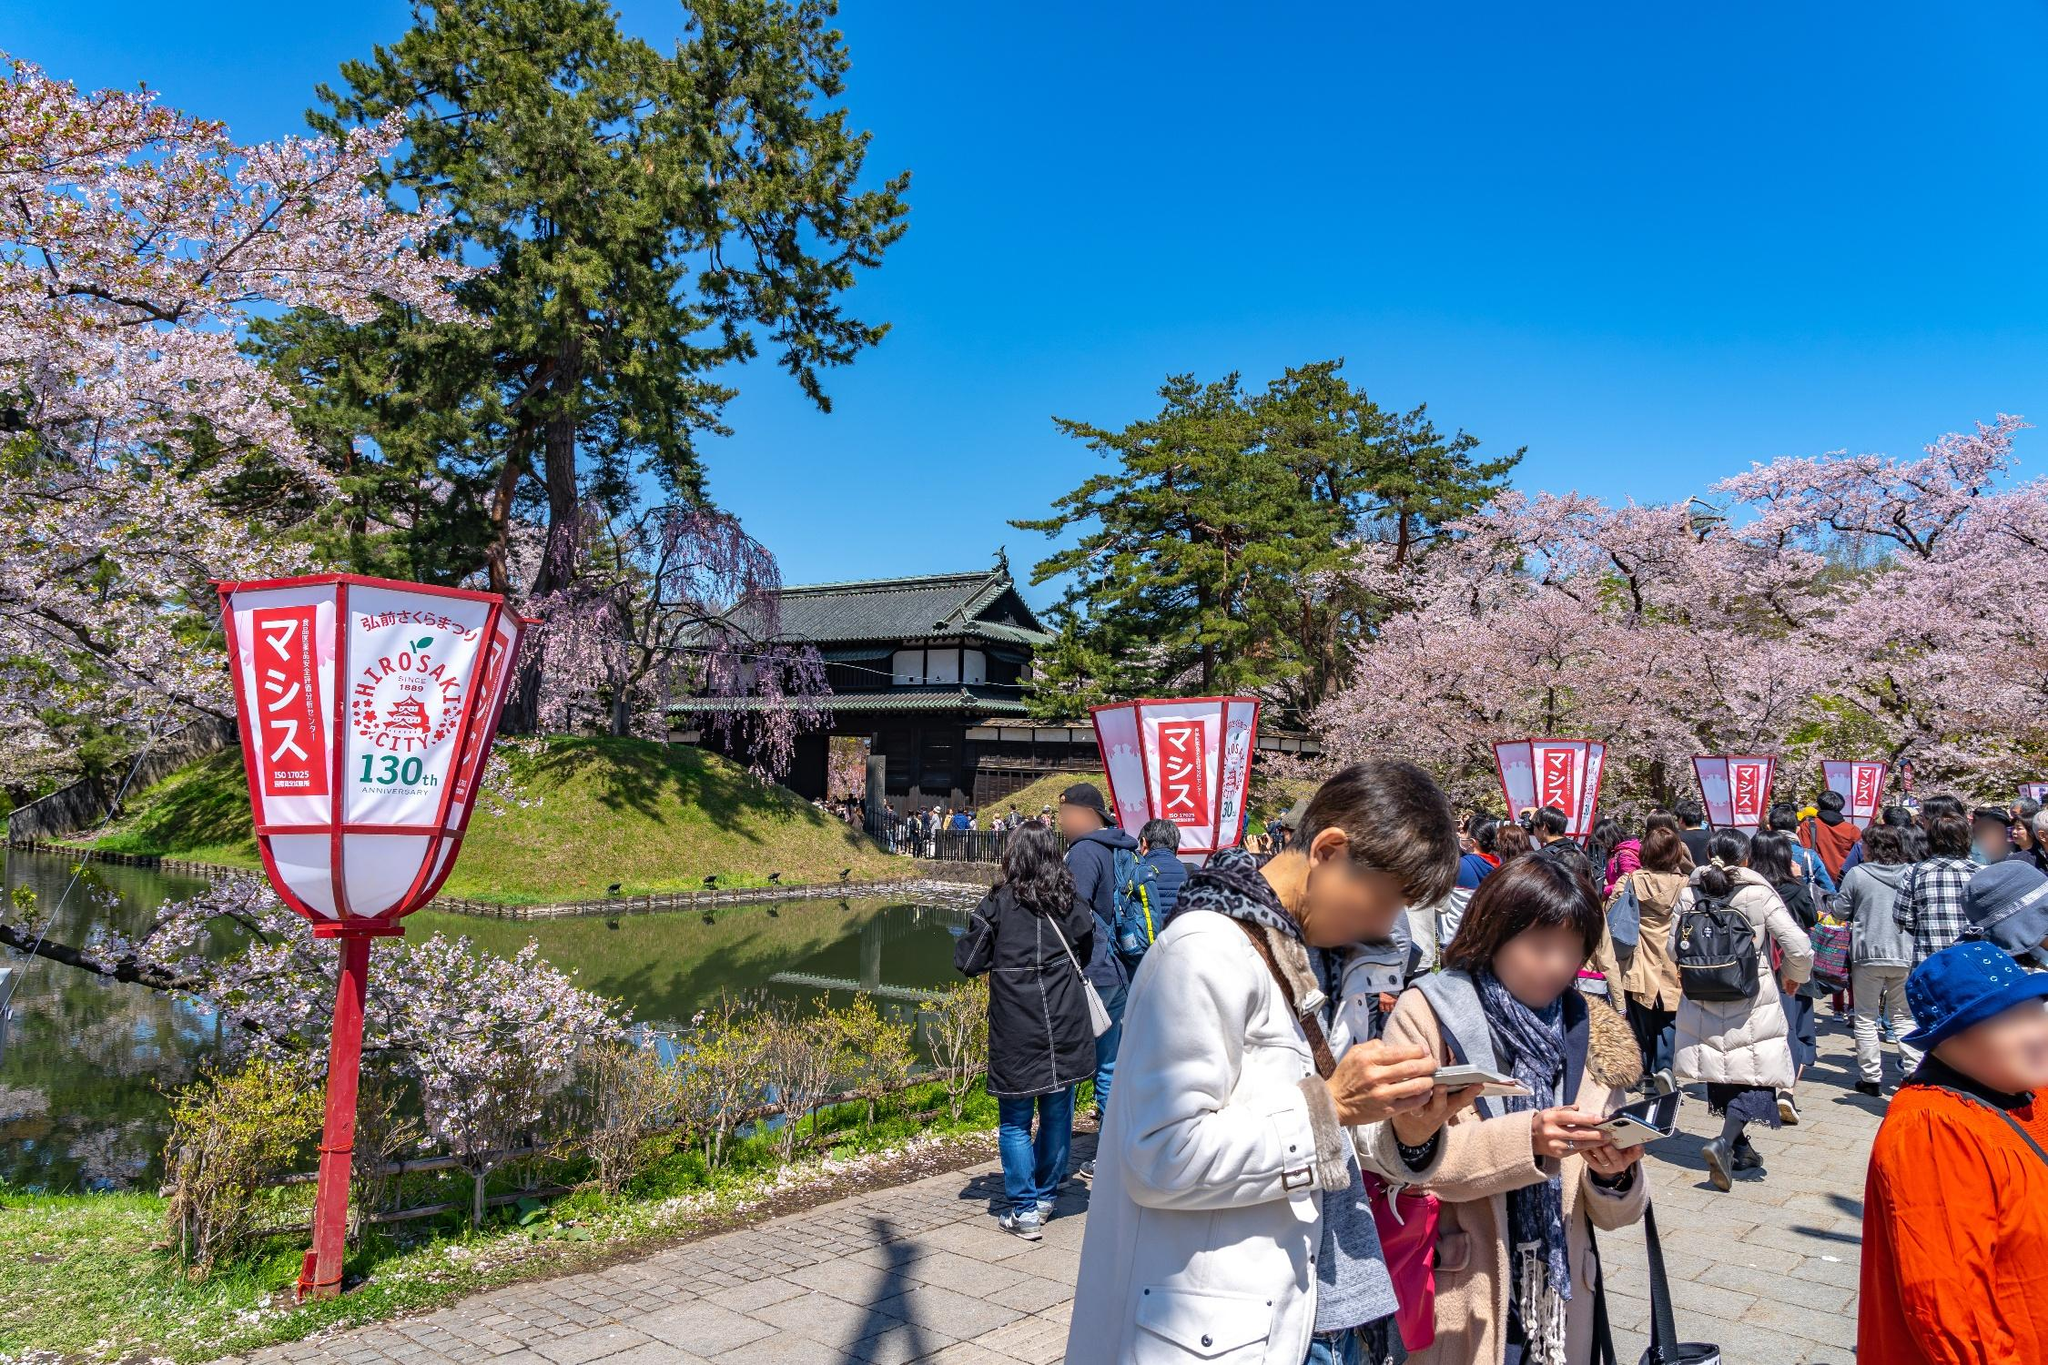What are the key elements in this picture? The image showcases a lively scene at Hirosaki Castle during the cherry blossom season, celebrating its 130th anniversary. Central elements include the majestic Hirosaki Castle in the background, surrounded by beautiful cherry blossom trees in full bloom, their pink petals enriching the scene. The serene moat, reflecting the blossoms, adds a peaceful element. In the foreground, a lush green embankment and a path bustling with visitors provide a sense of scale and activity, with people enjoying the festive atmosphere. Traditional red lanterns line the path, contributing to the cultural authenticity. The clear blue sky completes the picturesque setting, enhancing the vibrant colors below. 